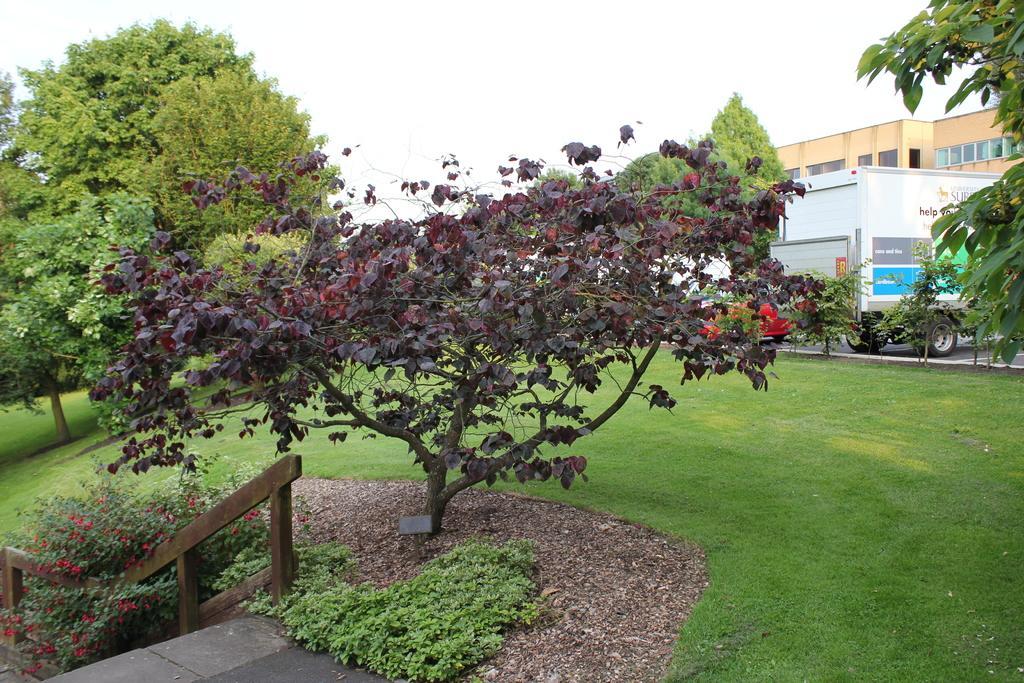Could you give a brief overview of what you see in this image? In the image there are trees on the grassland and in the back there is a building on the right side with a vehicle in front of it on the road and above its sky. 